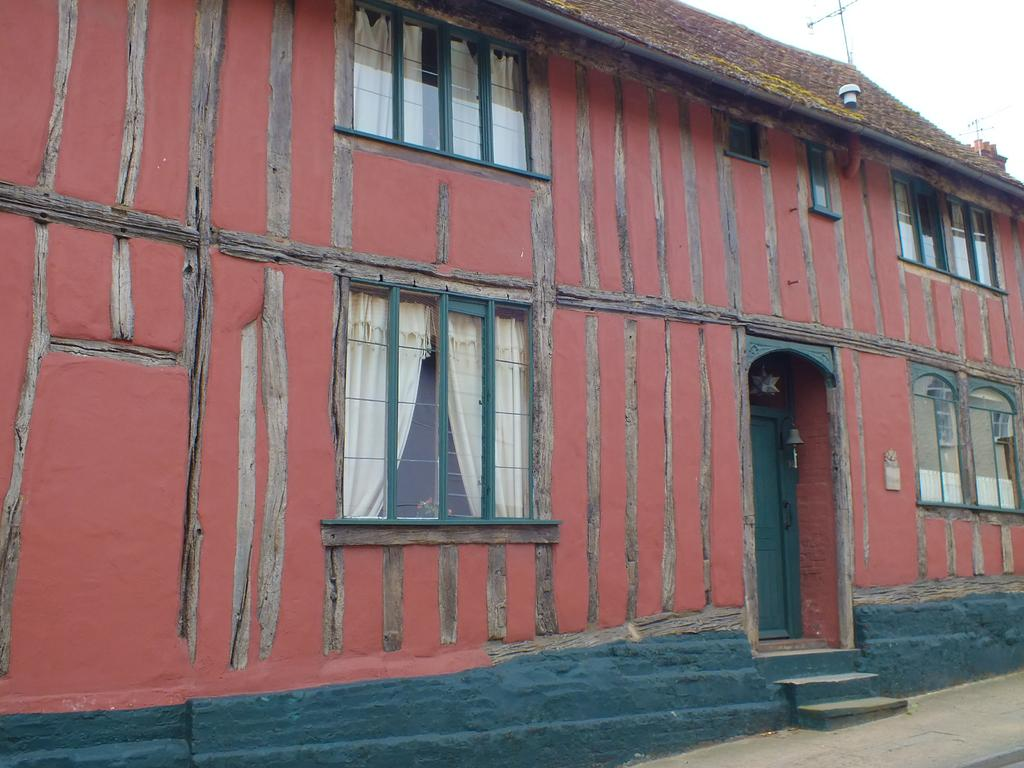What type of structure is visible in the image? There is a house in the image. What material is used for the door of the house? The house has a wooden door. What feature is present on the house for visitors to ring? The house has a bell. What type of material is used for the windows of the house? The house has glass elements and windows. What is located on top of the house? There is an antenna on top of the house. How can someone access the entrance of the house? There are steps in front of the door. What type of scissors can be seen cutting the grass in the image? There are no scissors or grass cutting activity visible in the image. 